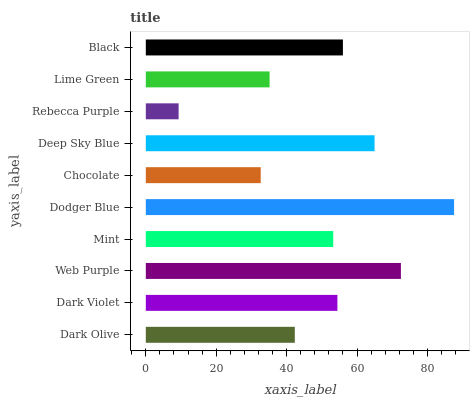Is Rebecca Purple the minimum?
Answer yes or no. Yes. Is Dodger Blue the maximum?
Answer yes or no. Yes. Is Dark Violet the minimum?
Answer yes or no. No. Is Dark Violet the maximum?
Answer yes or no. No. Is Dark Violet greater than Dark Olive?
Answer yes or no. Yes. Is Dark Olive less than Dark Violet?
Answer yes or no. Yes. Is Dark Olive greater than Dark Violet?
Answer yes or no. No. Is Dark Violet less than Dark Olive?
Answer yes or no. No. Is Dark Violet the high median?
Answer yes or no. Yes. Is Mint the low median?
Answer yes or no. Yes. Is Black the high median?
Answer yes or no. No. Is Deep Sky Blue the low median?
Answer yes or no. No. 